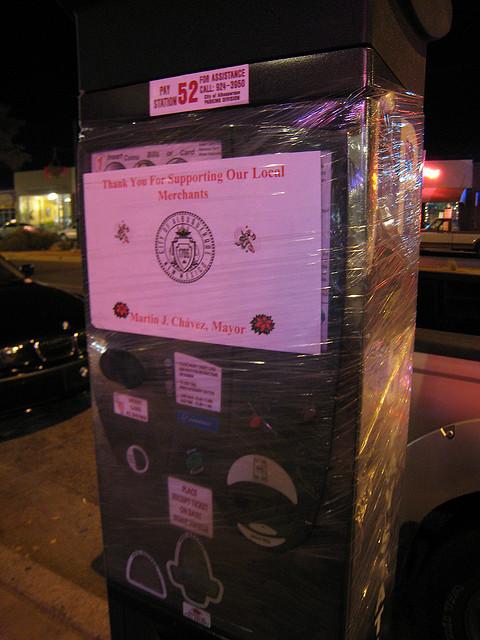What language is that?
Concise answer only. English. Is the machine wrapped in plastic?
Answer briefly. Yes. What is the number at the top?
Concise answer only. 52. 